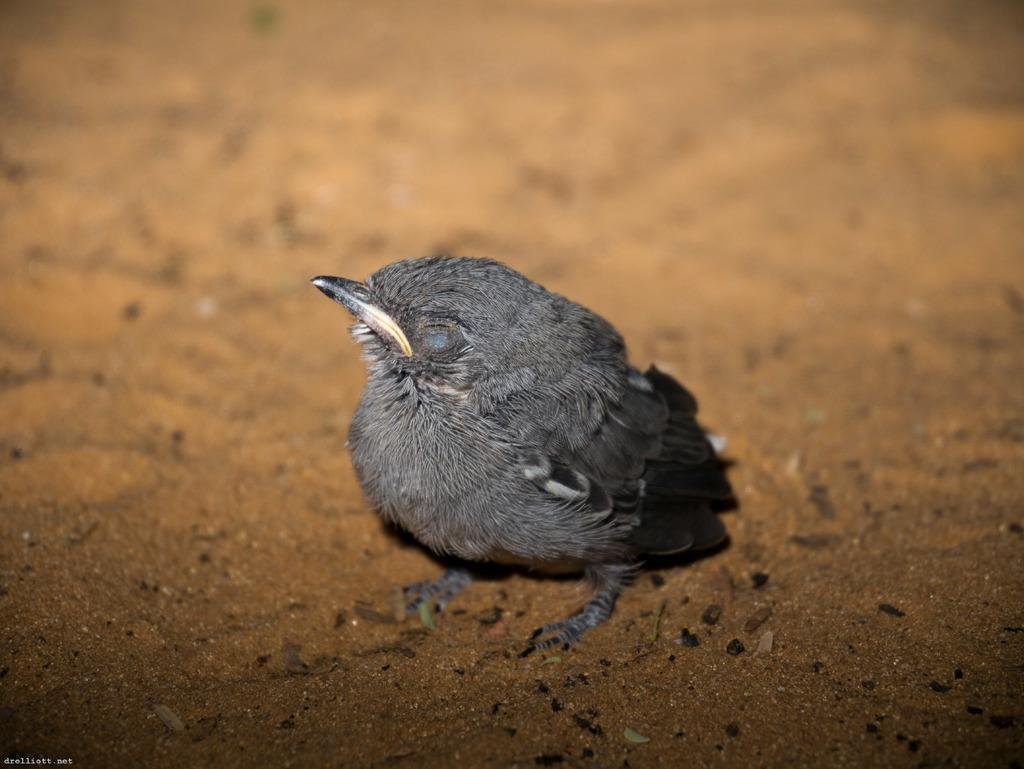What is the main subject of the image? There is a small bird in the center of the image. Can you describe the bird in the image? The bird is small and located in the center of the image. What might the bird be doing in the image? The bird's actions are not specified, but it is likely perched or flying. Can you see the rabbit swimming in the image? There is no rabbit or swimming activity present in the image; it features a small bird. 